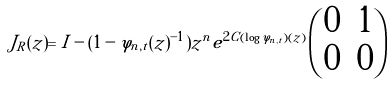<formula> <loc_0><loc_0><loc_500><loc_500>J _ { R } ( z ) = I - ( 1 - \varphi _ { n , t } ( z ) ^ { - 1 } ) z ^ { n } e ^ { 2 C ( \log \varphi _ { n , t } ) ( z ) } \begin{pmatrix} 0 & 1 \\ 0 & 0 \end{pmatrix}</formula> 